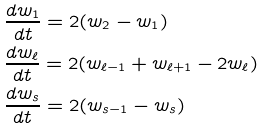<formula> <loc_0><loc_0><loc_500><loc_500>& \frac { d w _ { 1 } } { d t } = 2 ( w _ { 2 } - w _ { 1 } ) \\ & \frac { d w _ { \ell } } { d t } = 2 ( w _ { \ell - 1 } + w _ { \ell + 1 } - 2 w _ { \ell } ) \\ & \frac { d w _ { s } } { d t } = 2 ( w _ { s - 1 } - w _ { s } )</formula> 